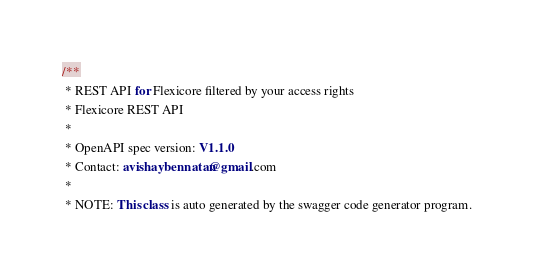<code> <loc_0><loc_0><loc_500><loc_500><_TypeScript_>

/**
 * REST API for Flexicore filtered by your access rights
 * Flexicore REST API
 *
 * OpenAPI spec version: V1.1.0
 * Contact: avishaybennatan@gmail.com
 *
 * NOTE: This class is auto generated by the swagger code generator program.</code> 